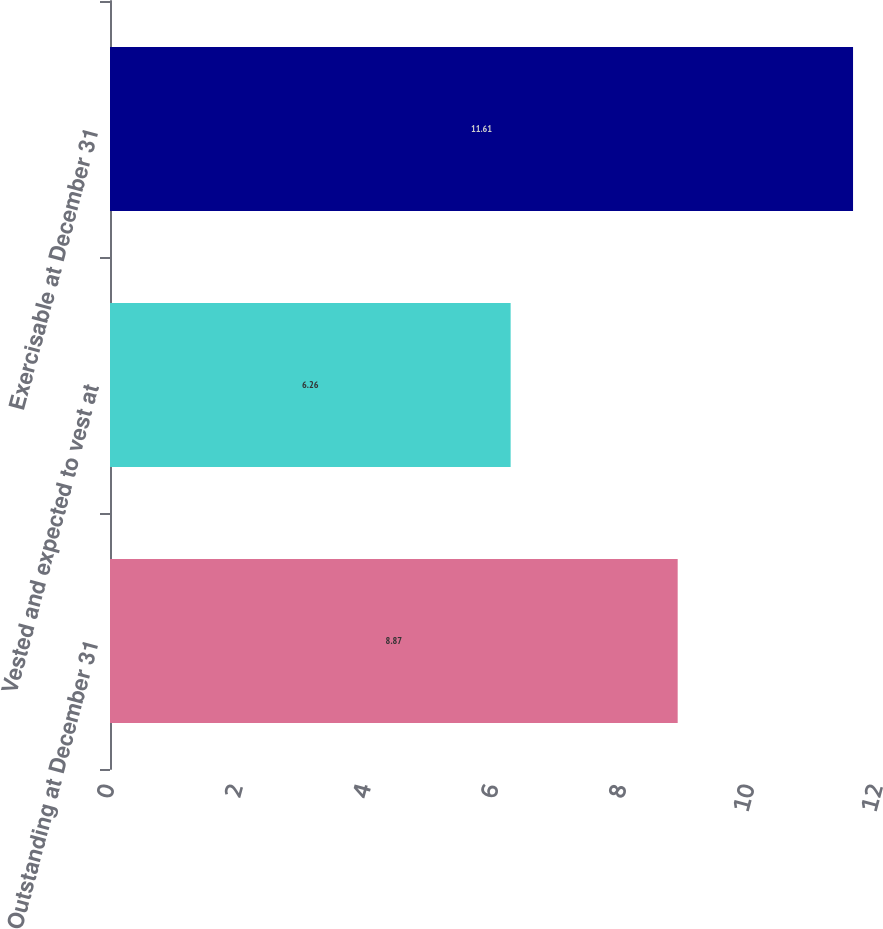Convert chart to OTSL. <chart><loc_0><loc_0><loc_500><loc_500><bar_chart><fcel>Outstanding at December 31<fcel>Vested and expected to vest at<fcel>Exercisable at December 31<nl><fcel>8.87<fcel>6.26<fcel>11.61<nl></chart> 